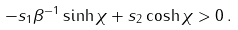Convert formula to latex. <formula><loc_0><loc_0><loc_500><loc_500>- s _ { 1 } \beta ^ { - 1 } \sinh { \chi } + s _ { 2 } \cosh { \chi } > 0 \, .</formula> 